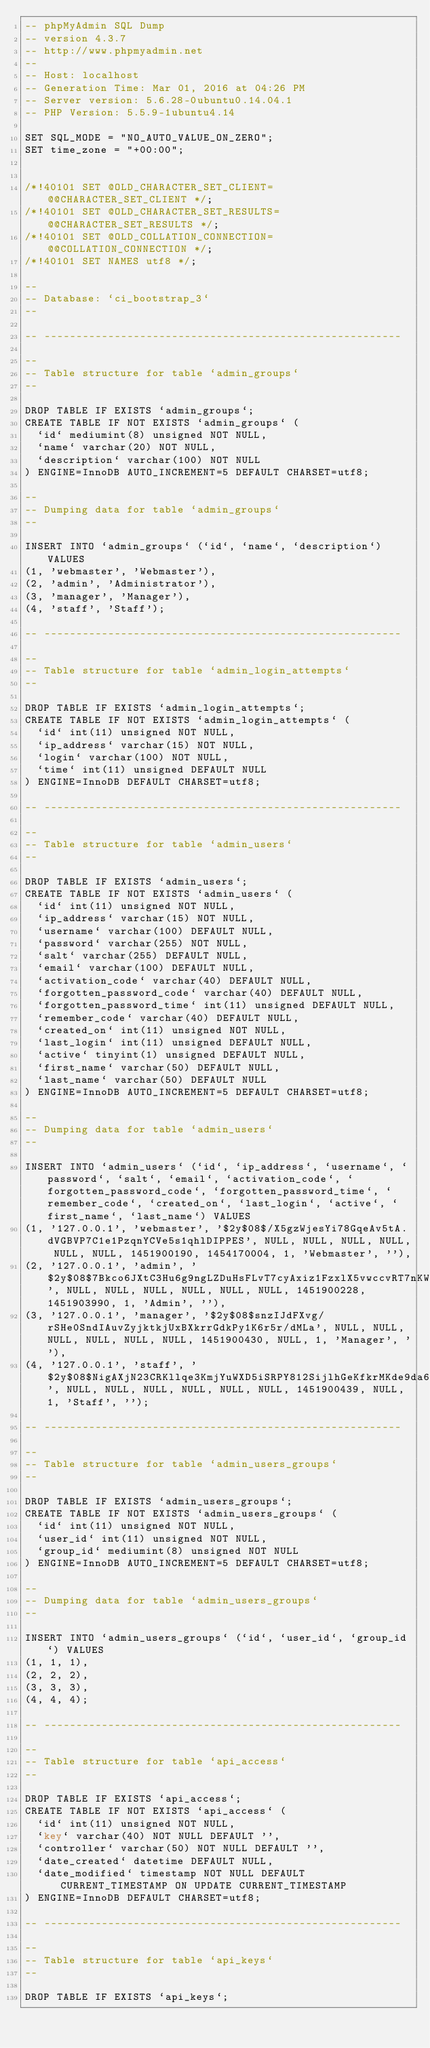Convert code to text. <code><loc_0><loc_0><loc_500><loc_500><_SQL_>-- phpMyAdmin SQL Dump
-- version 4.3.7
-- http://www.phpmyadmin.net
--
-- Host: localhost
-- Generation Time: Mar 01, 2016 at 04:26 PM
-- Server version: 5.6.28-0ubuntu0.14.04.1
-- PHP Version: 5.5.9-1ubuntu4.14

SET SQL_MODE = "NO_AUTO_VALUE_ON_ZERO";
SET time_zone = "+00:00";


/*!40101 SET @OLD_CHARACTER_SET_CLIENT=@@CHARACTER_SET_CLIENT */;
/*!40101 SET @OLD_CHARACTER_SET_RESULTS=@@CHARACTER_SET_RESULTS */;
/*!40101 SET @OLD_COLLATION_CONNECTION=@@COLLATION_CONNECTION */;
/*!40101 SET NAMES utf8 */;

--
-- Database: `ci_bootstrap_3`
--

-- --------------------------------------------------------

--
-- Table structure for table `admin_groups`
--

DROP TABLE IF EXISTS `admin_groups`;
CREATE TABLE IF NOT EXISTS `admin_groups` (
  `id` mediumint(8) unsigned NOT NULL,
  `name` varchar(20) NOT NULL,
  `description` varchar(100) NOT NULL
) ENGINE=InnoDB AUTO_INCREMENT=5 DEFAULT CHARSET=utf8;

--
-- Dumping data for table `admin_groups`
--

INSERT INTO `admin_groups` (`id`, `name`, `description`) VALUES
(1, 'webmaster', 'Webmaster'),
(2, 'admin', 'Administrator'),
(3, 'manager', 'Manager'),
(4, 'staff', 'Staff');

-- --------------------------------------------------------

--
-- Table structure for table `admin_login_attempts`
--

DROP TABLE IF EXISTS `admin_login_attempts`;
CREATE TABLE IF NOT EXISTS `admin_login_attempts` (
  `id` int(11) unsigned NOT NULL,
  `ip_address` varchar(15) NOT NULL,
  `login` varchar(100) NOT NULL,
  `time` int(11) unsigned DEFAULT NULL
) ENGINE=InnoDB DEFAULT CHARSET=utf8;

-- --------------------------------------------------------

--
-- Table structure for table `admin_users`
--

DROP TABLE IF EXISTS `admin_users`;
CREATE TABLE IF NOT EXISTS `admin_users` (
  `id` int(11) unsigned NOT NULL,
  `ip_address` varchar(15) NOT NULL,
  `username` varchar(100) DEFAULT NULL,
  `password` varchar(255) NOT NULL,
  `salt` varchar(255) DEFAULT NULL,
  `email` varchar(100) DEFAULT NULL,
  `activation_code` varchar(40) DEFAULT NULL,
  `forgotten_password_code` varchar(40) DEFAULT NULL,
  `forgotten_password_time` int(11) unsigned DEFAULT NULL,
  `remember_code` varchar(40) DEFAULT NULL,
  `created_on` int(11) unsigned NOT NULL,
  `last_login` int(11) unsigned DEFAULT NULL,
  `active` tinyint(1) unsigned DEFAULT NULL,
  `first_name` varchar(50) DEFAULT NULL,
  `last_name` varchar(50) DEFAULT NULL
) ENGINE=InnoDB AUTO_INCREMENT=5 DEFAULT CHARSET=utf8;

--
-- Dumping data for table `admin_users`
--

INSERT INTO `admin_users` (`id`, `ip_address`, `username`, `password`, `salt`, `email`, `activation_code`, `forgotten_password_code`, `forgotten_password_time`, `remember_code`, `created_on`, `last_login`, `active`, `first_name`, `last_name`) VALUES
(1, '127.0.0.1', 'webmaster', '$2y$08$/X5gzWjesYi78GqeAv5tA.dVGBVP7C1e1PzqnYCVe5s1qhlDIPPES', NULL, NULL, NULL, NULL, NULL, NULL, 1451900190, 1454170004, 1, 'Webmaster', ''),
(2, '127.0.0.1', 'admin', '$2y$08$7Bkco6JXtC3Hu6g9ngLZDuHsFLvT7cyAxiz1FzxlX5vwccvRT7nKW', NULL, NULL, NULL, NULL, NULL, NULL, 1451900228, 1451903990, 1, 'Admin', ''),
(3, '127.0.0.1', 'manager', '$2y$08$snzIJdFXvg/rSHe0SndIAuvZyjktkjUxBXkrrGdkPy1K6r5r/dMLa', NULL, NULL, NULL, NULL, NULL, NULL, 1451900430, NULL, 1, 'Manager', ''),
(4, '127.0.0.1', 'staff', '$2y$08$NigAXjN23CRKllqe3KmjYuWXD5iSRPY812SijlhGeKfkrMKde9da6', NULL, NULL, NULL, NULL, NULL, NULL, 1451900439, NULL, 1, 'Staff', '');

-- --------------------------------------------------------

--
-- Table structure for table `admin_users_groups`
--

DROP TABLE IF EXISTS `admin_users_groups`;
CREATE TABLE IF NOT EXISTS `admin_users_groups` (
  `id` int(11) unsigned NOT NULL,
  `user_id` int(11) unsigned NOT NULL,
  `group_id` mediumint(8) unsigned NOT NULL
) ENGINE=InnoDB AUTO_INCREMENT=5 DEFAULT CHARSET=utf8;

--
-- Dumping data for table `admin_users_groups`
--

INSERT INTO `admin_users_groups` (`id`, `user_id`, `group_id`) VALUES
(1, 1, 1),
(2, 2, 2),
(3, 3, 3),
(4, 4, 4);

-- --------------------------------------------------------

--
-- Table structure for table `api_access`
--

DROP TABLE IF EXISTS `api_access`;
CREATE TABLE IF NOT EXISTS `api_access` (
  `id` int(11) unsigned NOT NULL,
  `key` varchar(40) NOT NULL DEFAULT '',
  `controller` varchar(50) NOT NULL DEFAULT '',
  `date_created` datetime DEFAULT NULL,
  `date_modified` timestamp NOT NULL DEFAULT CURRENT_TIMESTAMP ON UPDATE CURRENT_TIMESTAMP
) ENGINE=InnoDB DEFAULT CHARSET=utf8;

-- --------------------------------------------------------

--
-- Table structure for table `api_keys`
--

DROP TABLE IF EXISTS `api_keys`;</code> 